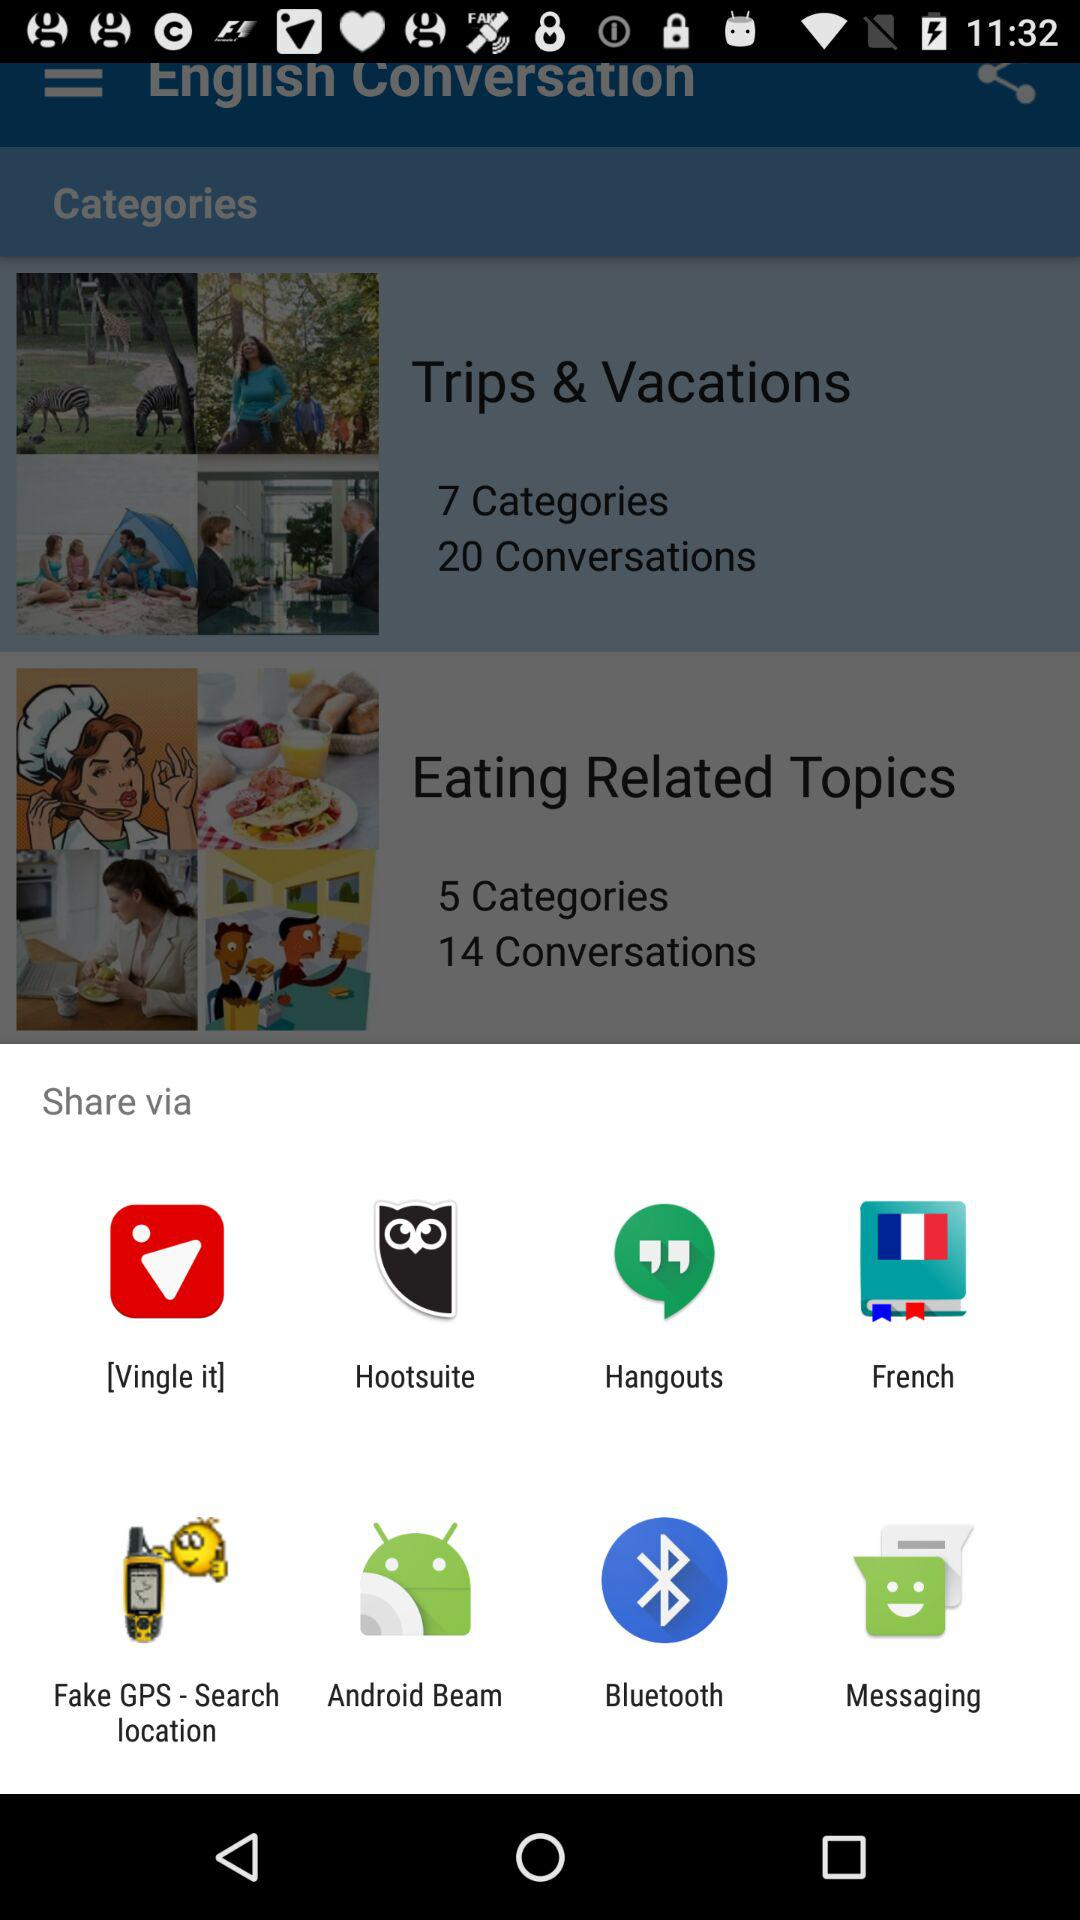How many categories are there in "Trips & Vacations"? There are 7 categories in "Trips & Vacations". 